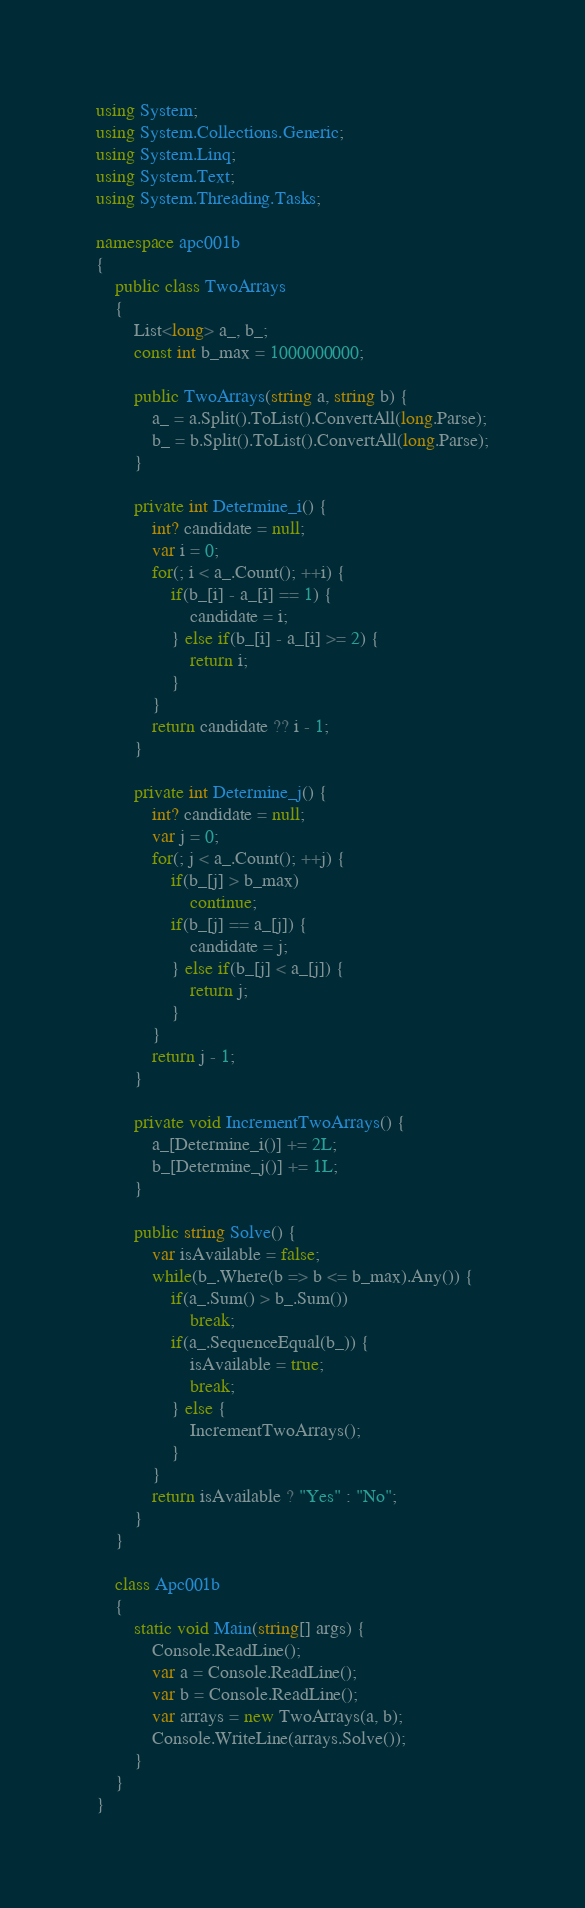<code> <loc_0><loc_0><loc_500><loc_500><_C#_>using System;
using System.Collections.Generic;
using System.Linq;
using System.Text;
using System.Threading.Tasks;

namespace apc001b
{
    public class TwoArrays
    {
        List<long> a_, b_;
        const int b_max = 1000000000;

        public TwoArrays(string a, string b) {
            a_ = a.Split().ToList().ConvertAll(long.Parse);
            b_ = b.Split().ToList().ConvertAll(long.Parse);
        }

        private int Determine_i() {
            int? candidate = null;
            var i = 0;
            for(; i < a_.Count(); ++i) {
                if(b_[i] - a_[i] == 1) {
                    candidate = i;
                } else if(b_[i] - a_[i] >= 2) {
                    return i;
                }
            }
            return candidate ?? i - 1;
        }

        private int Determine_j() {
            int? candidate = null;
            var j = 0;
            for(; j < a_.Count(); ++j) {
                if(b_[j] > b_max)
                    continue;
                if(b_[j] == a_[j]) {
                    candidate = j;
                } else if(b_[j] < a_[j]) {
                    return j;
                }
            }
            return j - 1;
        }

        private void IncrementTwoArrays() {
            a_[Determine_i()] += 2L;
            b_[Determine_j()] += 1L;
        }

        public string Solve() {
            var isAvailable = false;
            while(b_.Where(b => b <= b_max).Any()) {
                if(a_.Sum() > b_.Sum())
                    break;
                if(a_.SequenceEqual(b_)) {
                    isAvailable = true;
                    break;
                } else {
                    IncrementTwoArrays();
                }
            }
            return isAvailable ? "Yes" : "No";
        }
    }

    class Apc001b
    {
        static void Main(string[] args) {
            Console.ReadLine();
            var a = Console.ReadLine();
            var b = Console.ReadLine();
            var arrays = new TwoArrays(a, b);
            Console.WriteLine(arrays.Solve());
        }
    }
}
</code> 